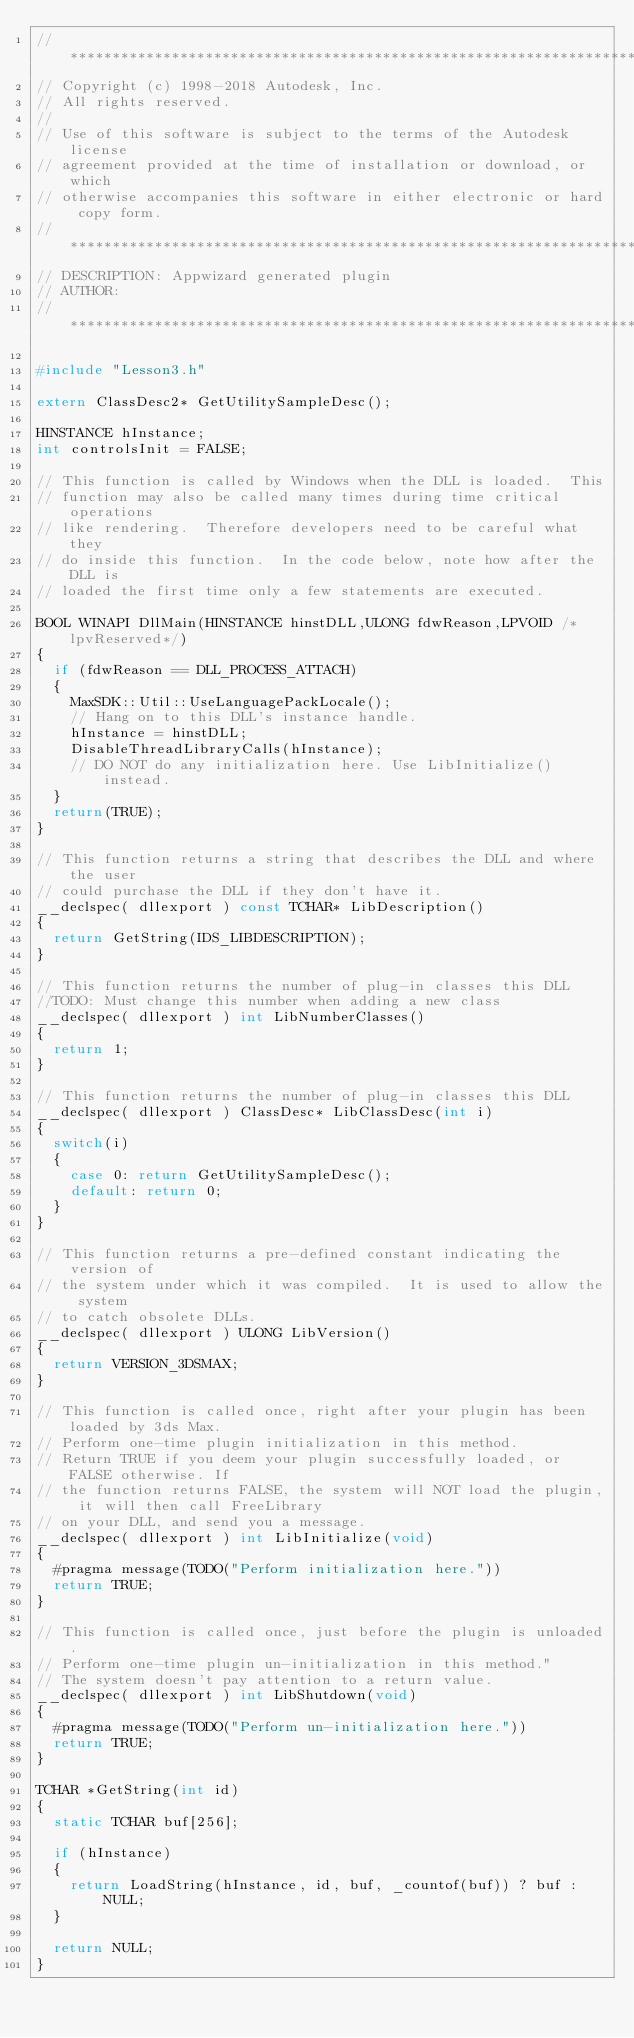Convert code to text. <code><loc_0><loc_0><loc_500><loc_500><_C++_>//**************************************************************************/
// Copyright (c) 1998-2018 Autodesk, Inc.
// All rights reserved.
// 
// Use of this software is subject to the terms of the Autodesk license 
// agreement provided at the time of installation or download, or which 
// otherwise accompanies this software in either electronic or hard copy form.
//**************************************************************************/
// DESCRIPTION: Appwizard generated plugin
// AUTHOR: 
//***************************************************************************/

#include "Lesson3.h"

extern ClassDesc2* GetUtilitySampleDesc();

HINSTANCE hInstance;
int controlsInit = FALSE;

// This function is called by Windows when the DLL is loaded.  This 
// function may also be called many times during time critical operations
// like rendering.  Therefore developers need to be careful what they
// do inside this function.  In the code below, note how after the DLL is
// loaded the first time only a few statements are executed.

BOOL WINAPI DllMain(HINSTANCE hinstDLL,ULONG fdwReason,LPVOID /*lpvReserved*/)
{
	if (fdwReason == DLL_PROCESS_ATTACH)
	{
		MaxSDK::Util::UseLanguagePackLocale();
		// Hang on to this DLL's instance handle.
		hInstance = hinstDLL;
		DisableThreadLibraryCalls(hInstance);
		// DO NOT do any initialization here. Use LibInitialize() instead.
	}
	return(TRUE);
}

// This function returns a string that describes the DLL and where the user
// could purchase the DLL if they don't have it.
__declspec( dllexport ) const TCHAR* LibDescription()
{
	return GetString(IDS_LIBDESCRIPTION);
}

// This function returns the number of plug-in classes this DLL
//TODO: Must change this number when adding a new class
__declspec( dllexport ) int LibNumberClasses()
{
	return 1;
}

// This function returns the number of plug-in classes this DLL
__declspec( dllexport ) ClassDesc* LibClassDesc(int i)
{
	switch(i)
	{
		case 0: return GetUtilitySampleDesc();
		default: return 0;
	}
}

// This function returns a pre-defined constant indicating the version of 
// the system under which it was compiled.  It is used to allow the system
// to catch obsolete DLLs.
__declspec( dllexport ) ULONG LibVersion()
{
	return VERSION_3DSMAX;
}

// This function is called once, right after your plugin has been loaded by 3ds Max. 
// Perform one-time plugin initialization in this method.
// Return TRUE if you deem your plugin successfully loaded, or FALSE otherwise. If 
// the function returns FALSE, the system will NOT load the plugin, it will then call FreeLibrary
// on your DLL, and send you a message.
__declspec( dllexport ) int LibInitialize(void)
{
	#pragma message(TODO("Perform initialization here."))
	return TRUE;
}

// This function is called once, just before the plugin is unloaded. 
// Perform one-time plugin un-initialization in this method."
// The system doesn't pay attention to a return value.
__declspec( dllexport ) int LibShutdown(void)
{
	#pragma message(TODO("Perform un-initialization here."))
	return TRUE;
}

TCHAR *GetString(int id)
{
	static TCHAR buf[256];

	if (hInstance)
	{
		return LoadString(hInstance, id, buf, _countof(buf)) ? buf : NULL;
	}

	return NULL;
}

</code> 